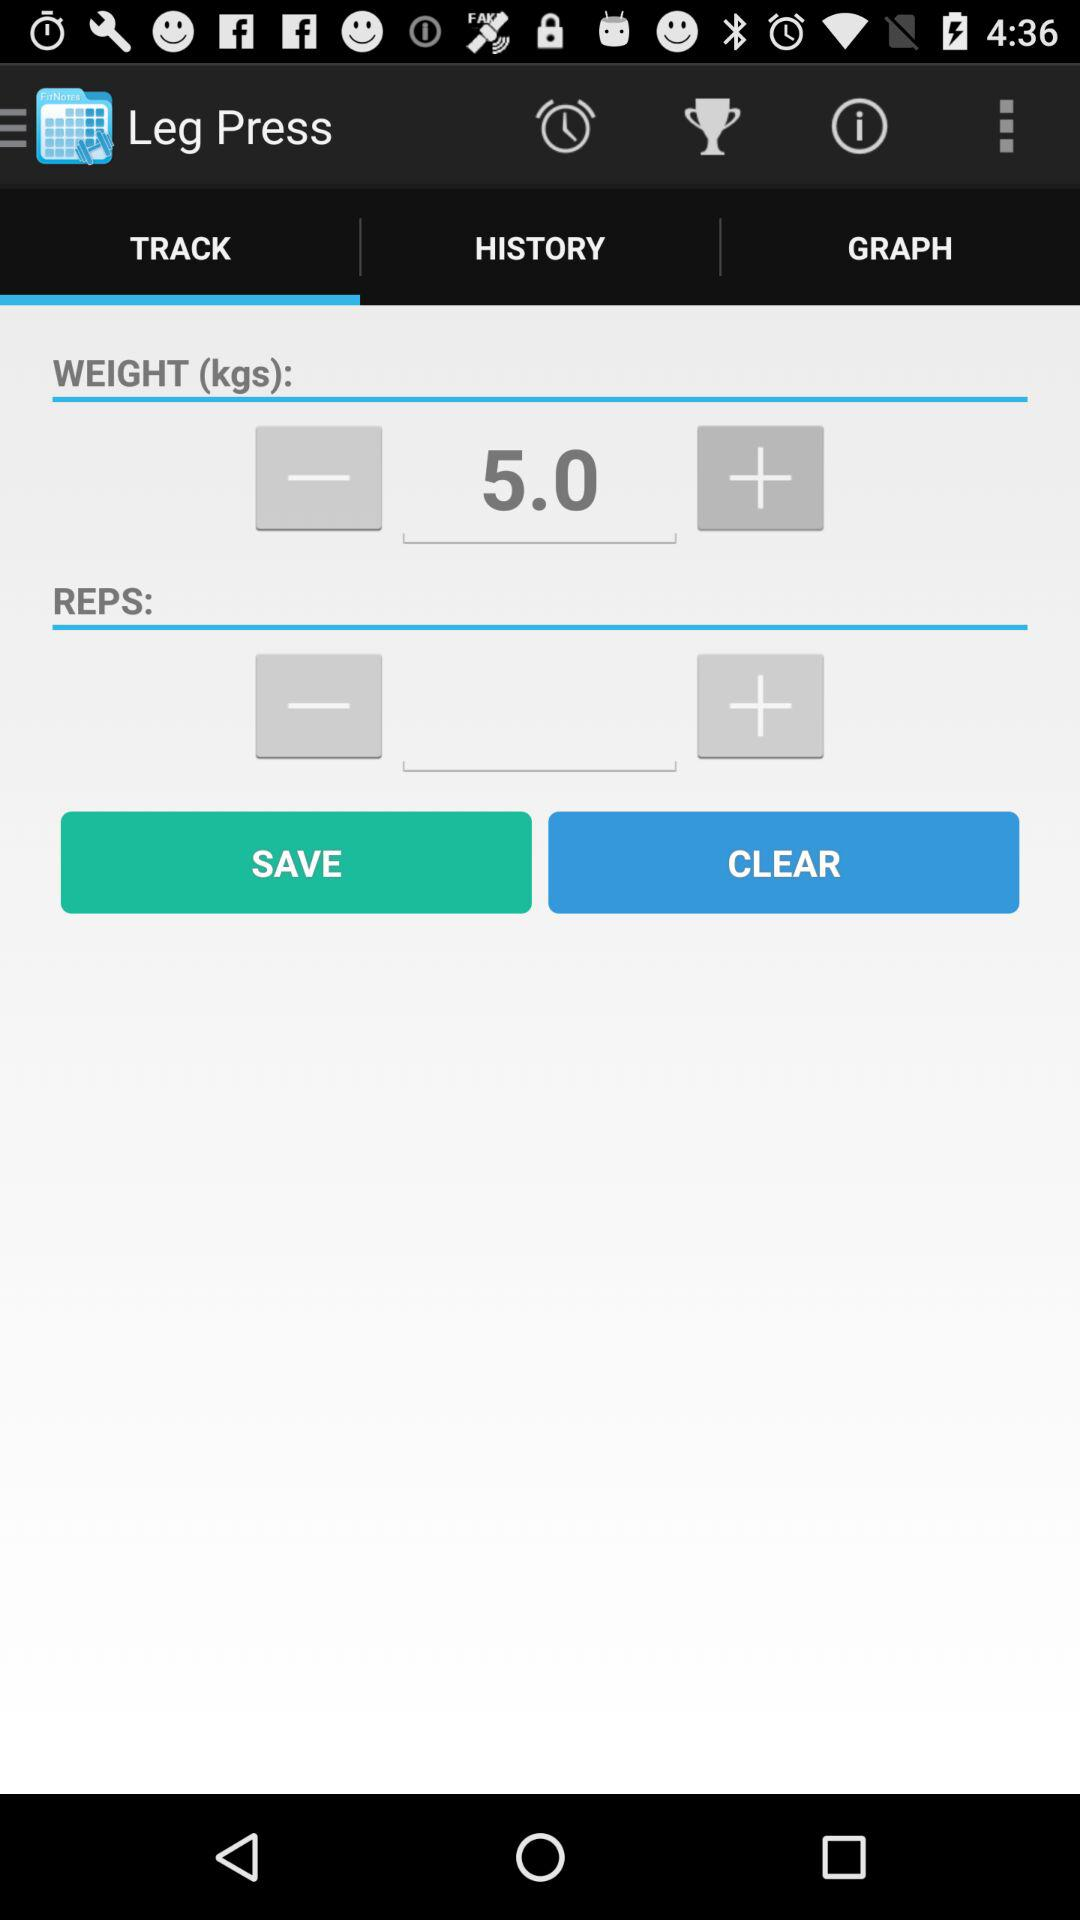What is the weight? The weight is 5 kilograms. 